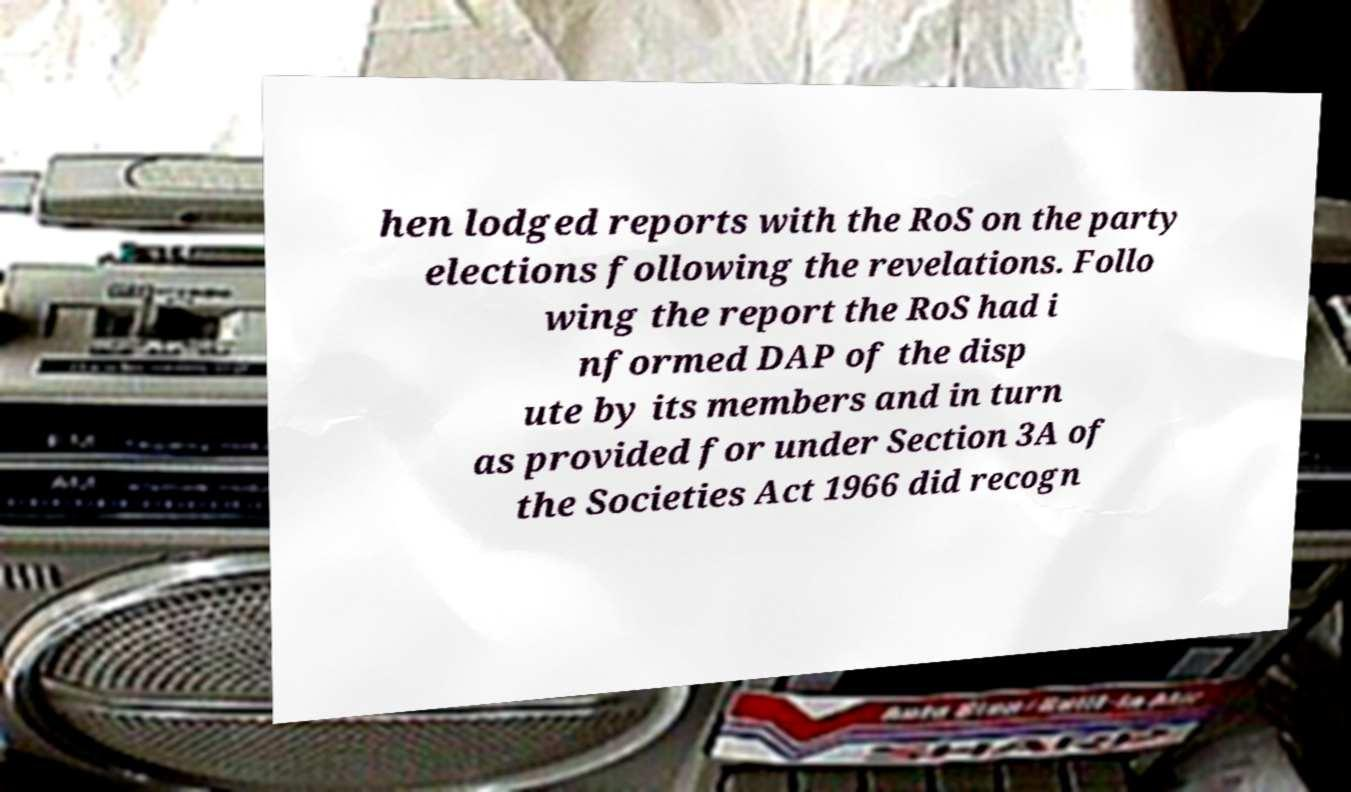Please read and relay the text visible in this image. What does it say? hen lodged reports with the RoS on the party elections following the revelations. Follo wing the report the RoS had i nformed DAP of the disp ute by its members and in turn as provided for under Section 3A of the Societies Act 1966 did recogn 